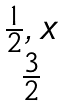<formula> <loc_0><loc_0><loc_500><loc_500>\begin{matrix} { \frac { 1 } { 2 } , x } \\ { \frac { 3 } { 2 } } \end{matrix}</formula> 